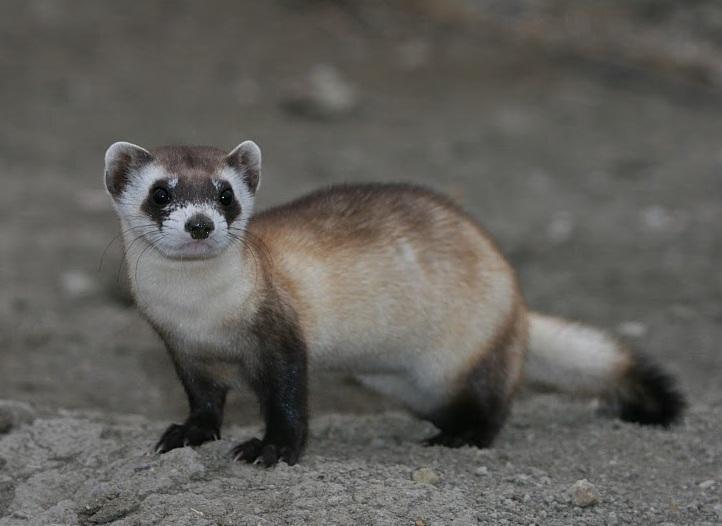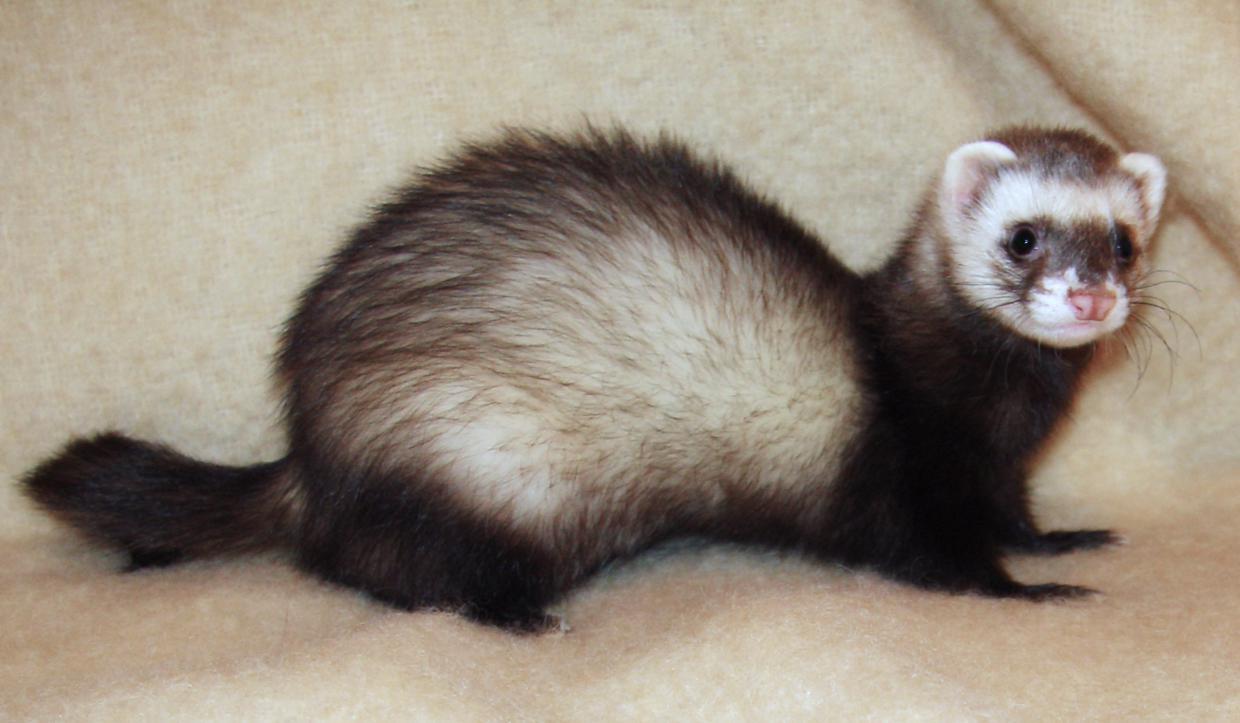The first image is the image on the left, the second image is the image on the right. Assess this claim about the two images: "There are multiple fuzzy animals facing the same direction in each image.". Correct or not? Answer yes or no. No. The first image is the image on the left, the second image is the image on the right. For the images displayed, is the sentence "At least one image has a single animal standing alone." factually correct? Answer yes or no. Yes. 